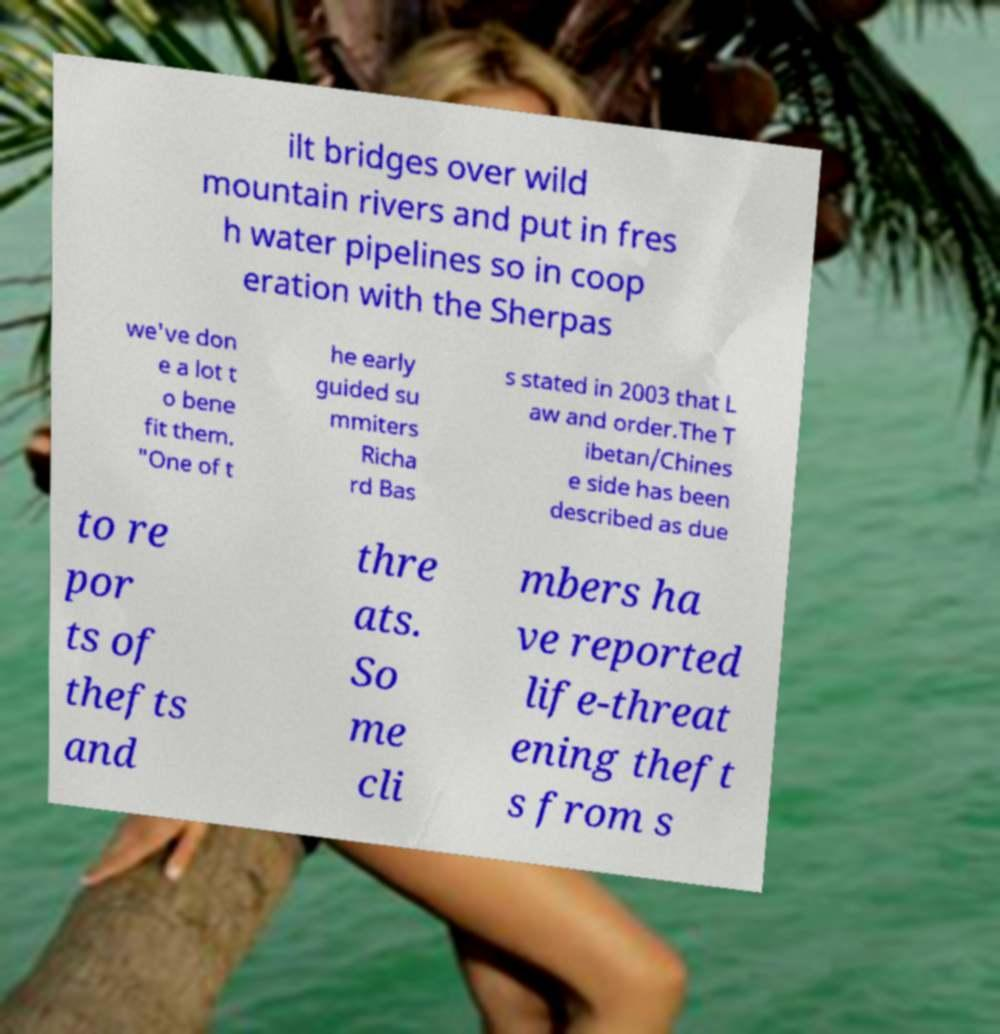For documentation purposes, I need the text within this image transcribed. Could you provide that? ilt bridges over wild mountain rivers and put in fres h water pipelines so in coop eration with the Sherpas we've don e a lot t o bene fit them. "One of t he early guided su mmiters Richa rd Bas s stated in 2003 that L aw and order.The T ibetan/Chines e side has been described as due to re por ts of thefts and thre ats. So me cli mbers ha ve reported life-threat ening theft s from s 